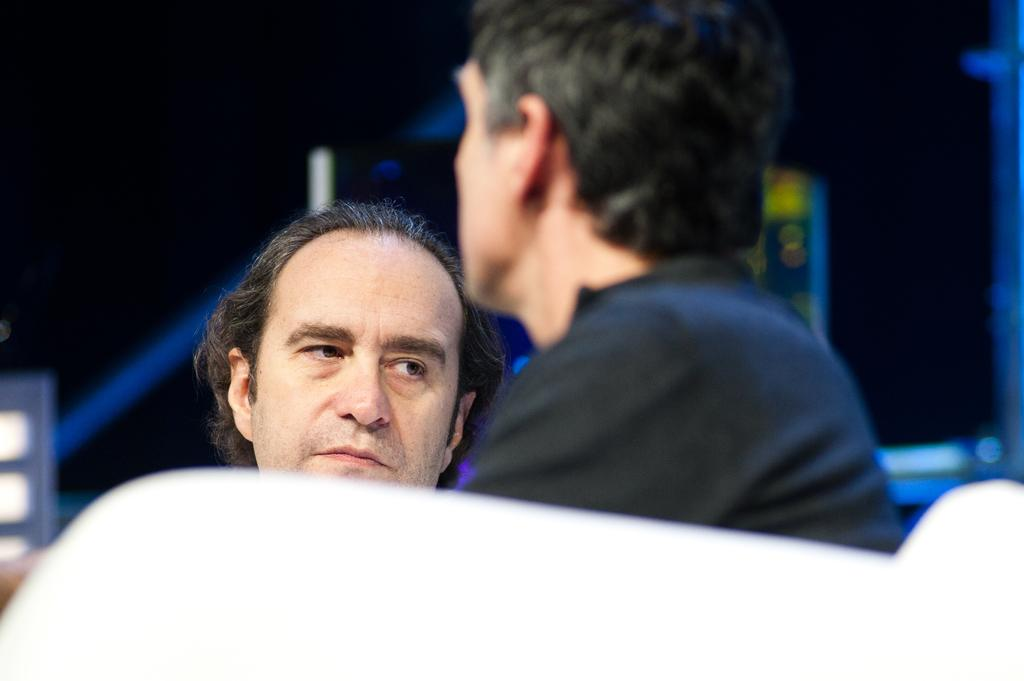How many people are present in the image? There are men in the image, but the exact number is not specified. Can you describe the men in the image? The provided facts do not give any information about the appearance or actions of the men. What is the setting or context of the image? The only fact given is that there are men in the image, so we cannot determine the setting or context. How many islands can be seen in the image? There is no mention of islands in the image, so we cannot answer this question. 